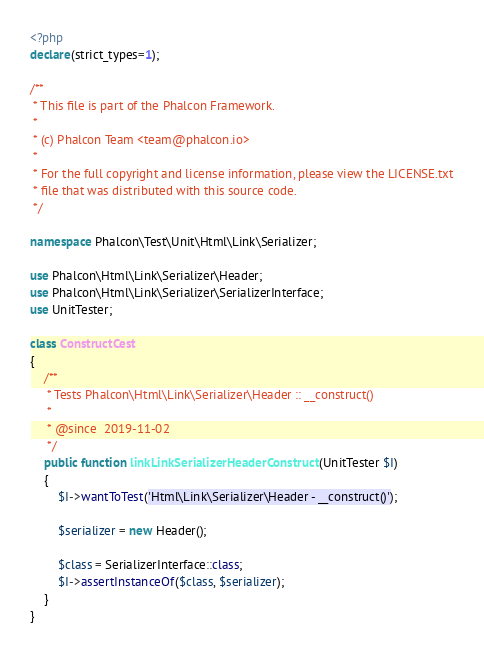<code> <loc_0><loc_0><loc_500><loc_500><_PHP_><?php
declare(strict_types=1);

/**
 * This file is part of the Phalcon Framework.
 *
 * (c) Phalcon Team <team@phalcon.io>
 *
 * For the full copyright and license information, please view the LICENSE.txt
 * file that was distributed with this source code.
 */

namespace Phalcon\Test\Unit\Html\Link\Serializer;

use Phalcon\Html\Link\Serializer\Header;
use Phalcon\Html\Link\Serializer\SerializerInterface;
use UnitTester;

class ConstructCest
{
    /**
     * Tests Phalcon\Html\Link\Serializer\Header :: __construct()
     *
     * @since  2019-11-02
     */
    public function linkLinkSerializerHeaderConstruct(UnitTester $I)
    {
        $I->wantToTest('Html\Link\Serializer\Header - __construct()');

        $serializer = new Header();

        $class = SerializerInterface::class;
        $I->assertInstanceOf($class, $serializer);
    }
}
</code> 